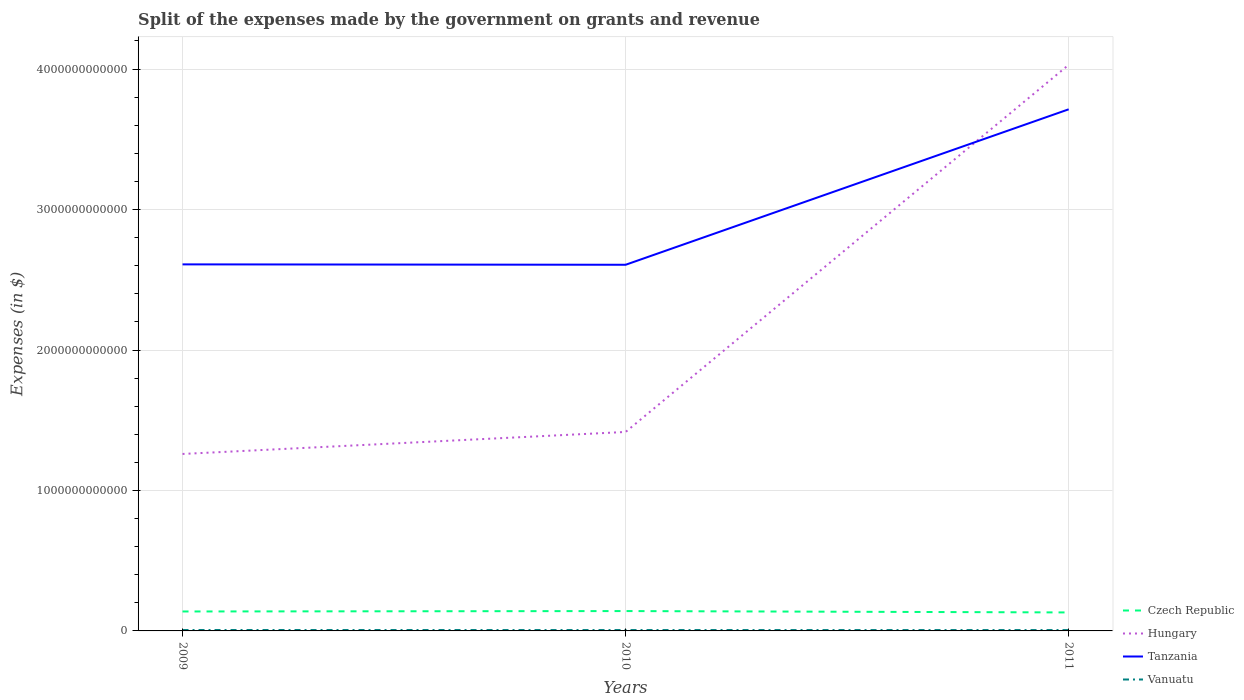How many different coloured lines are there?
Your answer should be compact. 4. Across all years, what is the maximum expenses made by the government on grants and revenue in Tanzania?
Your answer should be very brief. 2.61e+12. What is the total expenses made by the government on grants and revenue in Czech Republic in the graph?
Provide a short and direct response. 9.80e+09. What is the difference between the highest and the second highest expenses made by the government on grants and revenue in Czech Republic?
Your response must be concise. 9.80e+09. Is the expenses made by the government on grants and revenue in Czech Republic strictly greater than the expenses made by the government on grants and revenue in Tanzania over the years?
Provide a short and direct response. Yes. How many lines are there?
Offer a terse response. 4. What is the difference between two consecutive major ticks on the Y-axis?
Provide a succinct answer. 1.00e+12. Where does the legend appear in the graph?
Provide a short and direct response. Bottom right. How are the legend labels stacked?
Your answer should be compact. Vertical. What is the title of the graph?
Offer a very short reply. Split of the expenses made by the government on grants and revenue. What is the label or title of the Y-axis?
Offer a terse response. Expenses (in $). What is the Expenses (in $) of Czech Republic in 2009?
Your answer should be very brief. 1.38e+11. What is the Expenses (in $) of Hungary in 2009?
Provide a succinct answer. 1.26e+12. What is the Expenses (in $) of Tanzania in 2009?
Keep it short and to the point. 2.61e+12. What is the Expenses (in $) in Vanuatu in 2009?
Offer a very short reply. 6.46e+09. What is the Expenses (in $) in Czech Republic in 2010?
Your answer should be compact. 1.41e+11. What is the Expenses (in $) of Hungary in 2010?
Make the answer very short. 1.42e+12. What is the Expenses (in $) in Tanzania in 2010?
Provide a succinct answer. 2.61e+12. What is the Expenses (in $) in Vanuatu in 2010?
Provide a short and direct response. 6.19e+09. What is the Expenses (in $) in Czech Republic in 2011?
Keep it short and to the point. 1.32e+11. What is the Expenses (in $) of Hungary in 2011?
Offer a very short reply. 4.03e+12. What is the Expenses (in $) in Tanzania in 2011?
Offer a terse response. 3.71e+12. What is the Expenses (in $) in Vanuatu in 2011?
Your response must be concise. 6.12e+09. Across all years, what is the maximum Expenses (in $) in Czech Republic?
Offer a terse response. 1.41e+11. Across all years, what is the maximum Expenses (in $) in Hungary?
Offer a very short reply. 4.03e+12. Across all years, what is the maximum Expenses (in $) of Tanzania?
Make the answer very short. 3.71e+12. Across all years, what is the maximum Expenses (in $) of Vanuatu?
Your answer should be compact. 6.46e+09. Across all years, what is the minimum Expenses (in $) of Czech Republic?
Make the answer very short. 1.32e+11. Across all years, what is the minimum Expenses (in $) of Hungary?
Ensure brevity in your answer.  1.26e+12. Across all years, what is the minimum Expenses (in $) of Tanzania?
Provide a succinct answer. 2.61e+12. Across all years, what is the minimum Expenses (in $) of Vanuatu?
Keep it short and to the point. 6.12e+09. What is the total Expenses (in $) in Czech Republic in the graph?
Your answer should be compact. 4.11e+11. What is the total Expenses (in $) in Hungary in the graph?
Provide a short and direct response. 6.71e+12. What is the total Expenses (in $) in Tanzania in the graph?
Offer a terse response. 8.93e+12. What is the total Expenses (in $) in Vanuatu in the graph?
Give a very brief answer. 1.88e+1. What is the difference between the Expenses (in $) of Czech Republic in 2009 and that in 2010?
Your answer should be very brief. -2.96e+09. What is the difference between the Expenses (in $) of Hungary in 2009 and that in 2010?
Your answer should be compact. -1.57e+11. What is the difference between the Expenses (in $) in Tanzania in 2009 and that in 2010?
Offer a terse response. 2.83e+09. What is the difference between the Expenses (in $) of Vanuatu in 2009 and that in 2010?
Keep it short and to the point. 2.76e+08. What is the difference between the Expenses (in $) of Czech Republic in 2009 and that in 2011?
Your response must be concise. 6.84e+09. What is the difference between the Expenses (in $) of Hungary in 2009 and that in 2011?
Offer a terse response. -2.77e+12. What is the difference between the Expenses (in $) of Tanzania in 2009 and that in 2011?
Provide a short and direct response. -1.10e+12. What is the difference between the Expenses (in $) of Vanuatu in 2009 and that in 2011?
Ensure brevity in your answer.  3.48e+08. What is the difference between the Expenses (in $) of Czech Republic in 2010 and that in 2011?
Make the answer very short. 9.80e+09. What is the difference between the Expenses (in $) in Hungary in 2010 and that in 2011?
Give a very brief answer. -2.61e+12. What is the difference between the Expenses (in $) in Tanzania in 2010 and that in 2011?
Give a very brief answer. -1.11e+12. What is the difference between the Expenses (in $) of Vanuatu in 2010 and that in 2011?
Ensure brevity in your answer.  7.18e+07. What is the difference between the Expenses (in $) of Czech Republic in 2009 and the Expenses (in $) of Hungary in 2010?
Your answer should be compact. -1.28e+12. What is the difference between the Expenses (in $) in Czech Republic in 2009 and the Expenses (in $) in Tanzania in 2010?
Ensure brevity in your answer.  -2.47e+12. What is the difference between the Expenses (in $) of Czech Republic in 2009 and the Expenses (in $) of Vanuatu in 2010?
Ensure brevity in your answer.  1.32e+11. What is the difference between the Expenses (in $) in Hungary in 2009 and the Expenses (in $) in Tanzania in 2010?
Give a very brief answer. -1.35e+12. What is the difference between the Expenses (in $) of Hungary in 2009 and the Expenses (in $) of Vanuatu in 2010?
Your answer should be very brief. 1.25e+12. What is the difference between the Expenses (in $) of Tanzania in 2009 and the Expenses (in $) of Vanuatu in 2010?
Provide a succinct answer. 2.60e+12. What is the difference between the Expenses (in $) in Czech Republic in 2009 and the Expenses (in $) in Hungary in 2011?
Ensure brevity in your answer.  -3.89e+12. What is the difference between the Expenses (in $) of Czech Republic in 2009 and the Expenses (in $) of Tanzania in 2011?
Offer a terse response. -3.58e+12. What is the difference between the Expenses (in $) of Czech Republic in 2009 and the Expenses (in $) of Vanuatu in 2011?
Offer a very short reply. 1.32e+11. What is the difference between the Expenses (in $) of Hungary in 2009 and the Expenses (in $) of Tanzania in 2011?
Offer a terse response. -2.45e+12. What is the difference between the Expenses (in $) in Hungary in 2009 and the Expenses (in $) in Vanuatu in 2011?
Provide a succinct answer. 1.25e+12. What is the difference between the Expenses (in $) of Tanzania in 2009 and the Expenses (in $) of Vanuatu in 2011?
Your response must be concise. 2.60e+12. What is the difference between the Expenses (in $) in Czech Republic in 2010 and the Expenses (in $) in Hungary in 2011?
Keep it short and to the point. -3.89e+12. What is the difference between the Expenses (in $) in Czech Republic in 2010 and the Expenses (in $) in Tanzania in 2011?
Make the answer very short. -3.57e+12. What is the difference between the Expenses (in $) in Czech Republic in 2010 and the Expenses (in $) in Vanuatu in 2011?
Your answer should be very brief. 1.35e+11. What is the difference between the Expenses (in $) in Hungary in 2010 and the Expenses (in $) in Tanzania in 2011?
Keep it short and to the point. -2.30e+12. What is the difference between the Expenses (in $) in Hungary in 2010 and the Expenses (in $) in Vanuatu in 2011?
Provide a short and direct response. 1.41e+12. What is the difference between the Expenses (in $) in Tanzania in 2010 and the Expenses (in $) in Vanuatu in 2011?
Your answer should be very brief. 2.60e+12. What is the average Expenses (in $) of Czech Republic per year?
Offer a very short reply. 1.37e+11. What is the average Expenses (in $) in Hungary per year?
Offer a very short reply. 2.24e+12. What is the average Expenses (in $) in Tanzania per year?
Your answer should be compact. 2.98e+12. What is the average Expenses (in $) of Vanuatu per year?
Your response must be concise. 6.26e+09. In the year 2009, what is the difference between the Expenses (in $) of Czech Republic and Expenses (in $) of Hungary?
Make the answer very short. -1.12e+12. In the year 2009, what is the difference between the Expenses (in $) of Czech Republic and Expenses (in $) of Tanzania?
Your answer should be very brief. -2.47e+12. In the year 2009, what is the difference between the Expenses (in $) in Czech Republic and Expenses (in $) in Vanuatu?
Offer a terse response. 1.32e+11. In the year 2009, what is the difference between the Expenses (in $) of Hungary and Expenses (in $) of Tanzania?
Offer a terse response. -1.35e+12. In the year 2009, what is the difference between the Expenses (in $) in Hungary and Expenses (in $) in Vanuatu?
Provide a short and direct response. 1.25e+12. In the year 2009, what is the difference between the Expenses (in $) of Tanzania and Expenses (in $) of Vanuatu?
Make the answer very short. 2.60e+12. In the year 2010, what is the difference between the Expenses (in $) of Czech Republic and Expenses (in $) of Hungary?
Your answer should be compact. -1.28e+12. In the year 2010, what is the difference between the Expenses (in $) of Czech Republic and Expenses (in $) of Tanzania?
Provide a short and direct response. -2.47e+12. In the year 2010, what is the difference between the Expenses (in $) in Czech Republic and Expenses (in $) in Vanuatu?
Your answer should be very brief. 1.35e+11. In the year 2010, what is the difference between the Expenses (in $) in Hungary and Expenses (in $) in Tanzania?
Your answer should be very brief. -1.19e+12. In the year 2010, what is the difference between the Expenses (in $) of Hungary and Expenses (in $) of Vanuatu?
Keep it short and to the point. 1.41e+12. In the year 2010, what is the difference between the Expenses (in $) of Tanzania and Expenses (in $) of Vanuatu?
Provide a short and direct response. 2.60e+12. In the year 2011, what is the difference between the Expenses (in $) in Czech Republic and Expenses (in $) in Hungary?
Provide a succinct answer. -3.90e+12. In the year 2011, what is the difference between the Expenses (in $) of Czech Republic and Expenses (in $) of Tanzania?
Provide a short and direct response. -3.58e+12. In the year 2011, what is the difference between the Expenses (in $) in Czech Republic and Expenses (in $) in Vanuatu?
Offer a very short reply. 1.25e+11. In the year 2011, what is the difference between the Expenses (in $) of Hungary and Expenses (in $) of Tanzania?
Give a very brief answer. 3.17e+11. In the year 2011, what is the difference between the Expenses (in $) of Hungary and Expenses (in $) of Vanuatu?
Your answer should be compact. 4.02e+12. In the year 2011, what is the difference between the Expenses (in $) in Tanzania and Expenses (in $) in Vanuatu?
Provide a short and direct response. 3.71e+12. What is the ratio of the Expenses (in $) of Czech Republic in 2009 to that in 2010?
Offer a very short reply. 0.98. What is the ratio of the Expenses (in $) in Hungary in 2009 to that in 2010?
Offer a terse response. 0.89. What is the ratio of the Expenses (in $) in Tanzania in 2009 to that in 2010?
Offer a very short reply. 1. What is the ratio of the Expenses (in $) of Vanuatu in 2009 to that in 2010?
Provide a short and direct response. 1.04. What is the ratio of the Expenses (in $) in Czech Republic in 2009 to that in 2011?
Give a very brief answer. 1.05. What is the ratio of the Expenses (in $) of Hungary in 2009 to that in 2011?
Offer a terse response. 0.31. What is the ratio of the Expenses (in $) of Tanzania in 2009 to that in 2011?
Provide a short and direct response. 0.7. What is the ratio of the Expenses (in $) in Vanuatu in 2009 to that in 2011?
Give a very brief answer. 1.06. What is the ratio of the Expenses (in $) in Czech Republic in 2010 to that in 2011?
Your answer should be very brief. 1.07. What is the ratio of the Expenses (in $) in Hungary in 2010 to that in 2011?
Make the answer very short. 0.35. What is the ratio of the Expenses (in $) in Tanzania in 2010 to that in 2011?
Offer a very short reply. 0.7. What is the ratio of the Expenses (in $) of Vanuatu in 2010 to that in 2011?
Provide a succinct answer. 1.01. What is the difference between the highest and the second highest Expenses (in $) of Czech Republic?
Provide a short and direct response. 2.96e+09. What is the difference between the highest and the second highest Expenses (in $) of Hungary?
Provide a short and direct response. 2.61e+12. What is the difference between the highest and the second highest Expenses (in $) of Tanzania?
Ensure brevity in your answer.  1.10e+12. What is the difference between the highest and the second highest Expenses (in $) in Vanuatu?
Your answer should be compact. 2.76e+08. What is the difference between the highest and the lowest Expenses (in $) in Czech Republic?
Ensure brevity in your answer.  9.80e+09. What is the difference between the highest and the lowest Expenses (in $) of Hungary?
Make the answer very short. 2.77e+12. What is the difference between the highest and the lowest Expenses (in $) of Tanzania?
Your answer should be compact. 1.11e+12. What is the difference between the highest and the lowest Expenses (in $) of Vanuatu?
Make the answer very short. 3.48e+08. 